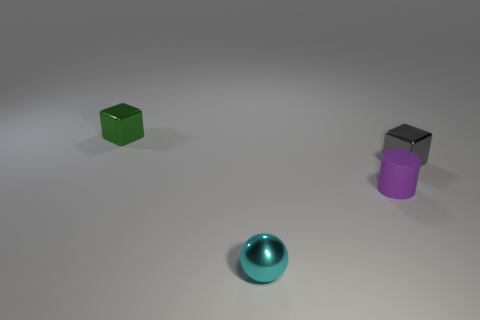Does the tiny metal object that is in front of the purple matte cylinder have the same color as the tiny rubber cylinder?
Ensure brevity in your answer.  No. There is a shiny object that is both in front of the tiny green thing and behind the cyan metal thing; how big is it?
Your answer should be compact. Small. How many tiny things are gray objects or purple matte things?
Provide a short and direct response. 2. What is the shape of the metal thing that is in front of the gray cube?
Your answer should be compact. Sphere. What number of purple rubber things are there?
Your response must be concise. 1. Are the tiny cyan thing and the small purple cylinder made of the same material?
Your answer should be very brief. No. Is the number of small cubes on the right side of the small rubber object greater than the number of green matte cubes?
Offer a very short reply. Yes. How many things are either big gray balls or small metallic blocks that are on the right side of the cylinder?
Provide a succinct answer. 1. Is the number of green things in front of the gray metal object greater than the number of small shiny objects left of the cyan object?
Your answer should be very brief. No. There is a small object behind the tiny block that is right of the tiny thing that is in front of the purple matte thing; what is its material?
Your answer should be compact. Metal. 